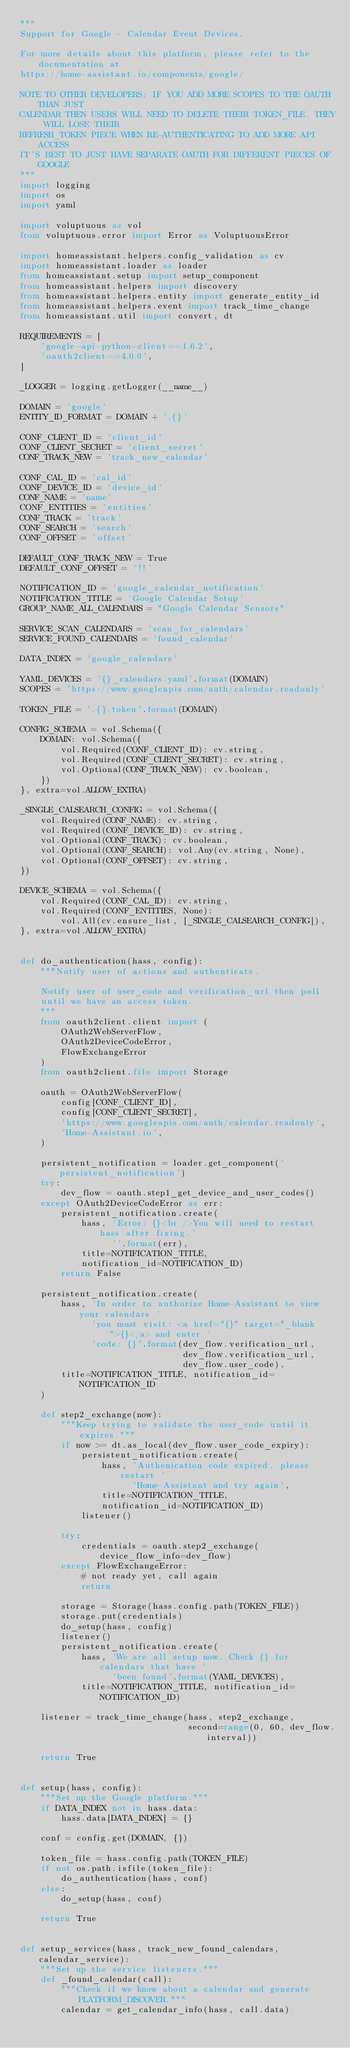<code> <loc_0><loc_0><loc_500><loc_500><_Python_>"""
Support for Google - Calendar Event Devices.

For more details about this platform, please refer to the documentation at
https://home-assistant.io/components/google/

NOTE TO OTHER DEVELOPERS: IF YOU ADD MORE SCOPES TO THE OAUTH THAN JUST
CALENDAR THEN USERS WILL NEED TO DELETE THEIR TOKEN_FILE. THEY WILL LOSE THEIR
REFRESH_TOKEN PIECE WHEN RE-AUTHENTICATING TO ADD MORE API ACCESS
IT'S BEST TO JUST HAVE SEPARATE OAUTH FOR DIFFERENT PIECES OF GOOGLE
"""
import logging
import os
import yaml

import voluptuous as vol
from voluptuous.error import Error as VoluptuousError

import homeassistant.helpers.config_validation as cv
import homeassistant.loader as loader
from homeassistant.setup import setup_component
from homeassistant.helpers import discovery
from homeassistant.helpers.entity import generate_entity_id
from homeassistant.helpers.event import track_time_change
from homeassistant.util import convert, dt

REQUIREMENTS = [
    'google-api-python-client==1.6.2',
    'oauth2client==4.0.0',
]

_LOGGER = logging.getLogger(__name__)

DOMAIN = 'google'
ENTITY_ID_FORMAT = DOMAIN + '.{}'

CONF_CLIENT_ID = 'client_id'
CONF_CLIENT_SECRET = 'client_secret'
CONF_TRACK_NEW = 'track_new_calendar'

CONF_CAL_ID = 'cal_id'
CONF_DEVICE_ID = 'device_id'
CONF_NAME = 'name'
CONF_ENTITIES = 'entities'
CONF_TRACK = 'track'
CONF_SEARCH = 'search'
CONF_OFFSET = 'offset'

DEFAULT_CONF_TRACK_NEW = True
DEFAULT_CONF_OFFSET = '!!'

NOTIFICATION_ID = 'google_calendar_notification'
NOTIFICATION_TITLE = 'Google Calendar Setup'
GROUP_NAME_ALL_CALENDARS = "Google Calendar Sensors"

SERVICE_SCAN_CALENDARS = 'scan_for_calendars'
SERVICE_FOUND_CALENDARS = 'found_calendar'

DATA_INDEX = 'google_calendars'

YAML_DEVICES = '{}_calendars.yaml'.format(DOMAIN)
SCOPES = 'https://www.googleapis.com/auth/calendar.readonly'

TOKEN_FILE = '.{}.token'.format(DOMAIN)

CONFIG_SCHEMA = vol.Schema({
    DOMAIN: vol.Schema({
        vol.Required(CONF_CLIENT_ID): cv.string,
        vol.Required(CONF_CLIENT_SECRET): cv.string,
        vol.Optional(CONF_TRACK_NEW): cv.boolean,
    })
}, extra=vol.ALLOW_EXTRA)

_SINGLE_CALSEARCH_CONFIG = vol.Schema({
    vol.Required(CONF_NAME): cv.string,
    vol.Required(CONF_DEVICE_ID): cv.string,
    vol.Optional(CONF_TRACK): cv.boolean,
    vol.Optional(CONF_SEARCH): vol.Any(cv.string, None),
    vol.Optional(CONF_OFFSET): cv.string,
})

DEVICE_SCHEMA = vol.Schema({
    vol.Required(CONF_CAL_ID): cv.string,
    vol.Required(CONF_ENTITIES, None):
        vol.All(cv.ensure_list, [_SINGLE_CALSEARCH_CONFIG]),
}, extra=vol.ALLOW_EXTRA)


def do_authentication(hass, config):
    """Notify user of actions and authenticate.

    Notify user of user_code and verification_url then poll
    until we have an access token.
    """
    from oauth2client.client import (
        OAuth2WebServerFlow,
        OAuth2DeviceCodeError,
        FlowExchangeError
    )
    from oauth2client.file import Storage

    oauth = OAuth2WebServerFlow(
        config[CONF_CLIENT_ID],
        config[CONF_CLIENT_SECRET],
        'https://www.googleapis.com/auth/calendar.readonly',
        'Home-Assistant.io',
    )

    persistent_notification = loader.get_component('persistent_notification')
    try:
        dev_flow = oauth.step1_get_device_and_user_codes()
    except OAuth2DeviceCodeError as err:
        persistent_notification.create(
            hass, 'Error: {}<br />You will need to restart hass after fixing.'
                  ''.format(err),
            title=NOTIFICATION_TITLE,
            notification_id=NOTIFICATION_ID)
        return False

    persistent_notification.create(
        hass, 'In order to authorize Home-Assistant to view your calendars '
              'you must visit: <a href="{}" target="_blank">{}</a> and enter '
              'code: {}'.format(dev_flow.verification_url,
                                dev_flow.verification_url,
                                dev_flow.user_code),
        title=NOTIFICATION_TITLE, notification_id=NOTIFICATION_ID
    )

    def step2_exchange(now):
        """Keep trying to validate the user_code until it expires."""
        if now >= dt.as_local(dev_flow.user_code_expiry):
            persistent_notification.create(
                hass, 'Authenication code expired, please restart '
                      'Home-Assistant and try again',
                title=NOTIFICATION_TITLE,
                notification_id=NOTIFICATION_ID)
            listener()

        try:
            credentials = oauth.step2_exchange(device_flow_info=dev_flow)
        except FlowExchangeError:
            # not ready yet, call again
            return

        storage = Storage(hass.config.path(TOKEN_FILE))
        storage.put(credentials)
        do_setup(hass, config)
        listener()
        persistent_notification.create(
            hass, 'We are all setup now. Check {} for calendars that have '
                  'been found'.format(YAML_DEVICES),
            title=NOTIFICATION_TITLE, notification_id=NOTIFICATION_ID)

    listener = track_time_change(hass, step2_exchange,
                                 second=range(0, 60, dev_flow.interval))

    return True


def setup(hass, config):
    """Set up the Google platform."""
    if DATA_INDEX not in hass.data:
        hass.data[DATA_INDEX] = {}

    conf = config.get(DOMAIN, {})

    token_file = hass.config.path(TOKEN_FILE)
    if not os.path.isfile(token_file):
        do_authentication(hass, conf)
    else:
        do_setup(hass, conf)

    return True


def setup_services(hass, track_new_found_calendars, calendar_service):
    """Set up the service listeners."""
    def _found_calendar(call):
        """Check if we know about a calendar and generate PLATFORM_DISCOVER."""
        calendar = get_calendar_info(hass, call.data)</code> 